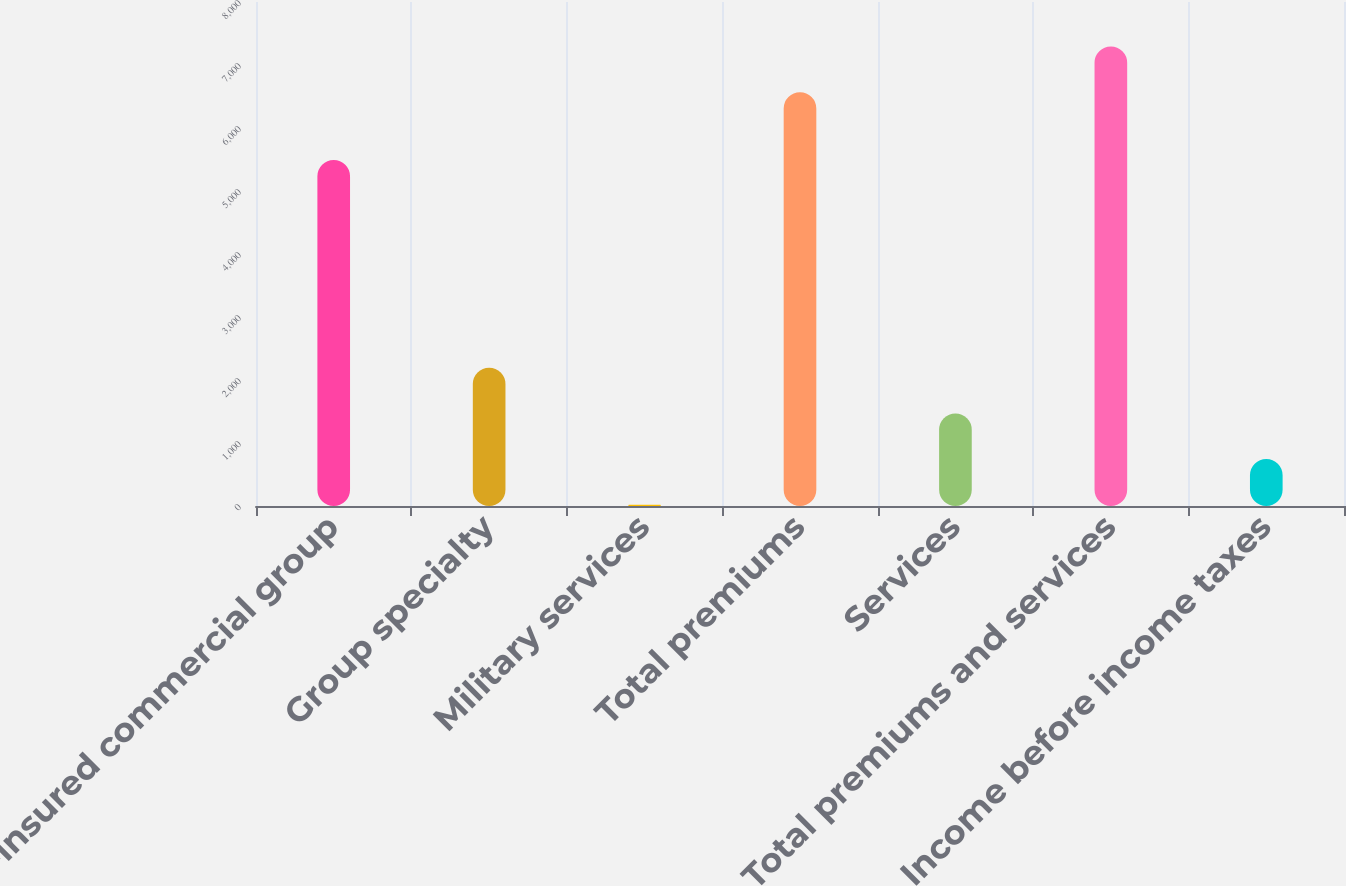Convert chart to OTSL. <chart><loc_0><loc_0><loc_500><loc_500><bar_chart><fcel>Fully-insured commercial group<fcel>Group specialty<fcel>Military services<fcel>Total premiums<fcel>Services<fcel>Total premiums and services<fcel>Income before income taxes<nl><fcel>5493<fcel>2194.8<fcel>21<fcel>6569<fcel>1470.2<fcel>7293.6<fcel>745.6<nl></chart> 